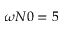Convert formula to latex. <formula><loc_0><loc_0><loc_500><loc_500>\omega N 0 = 5</formula> 